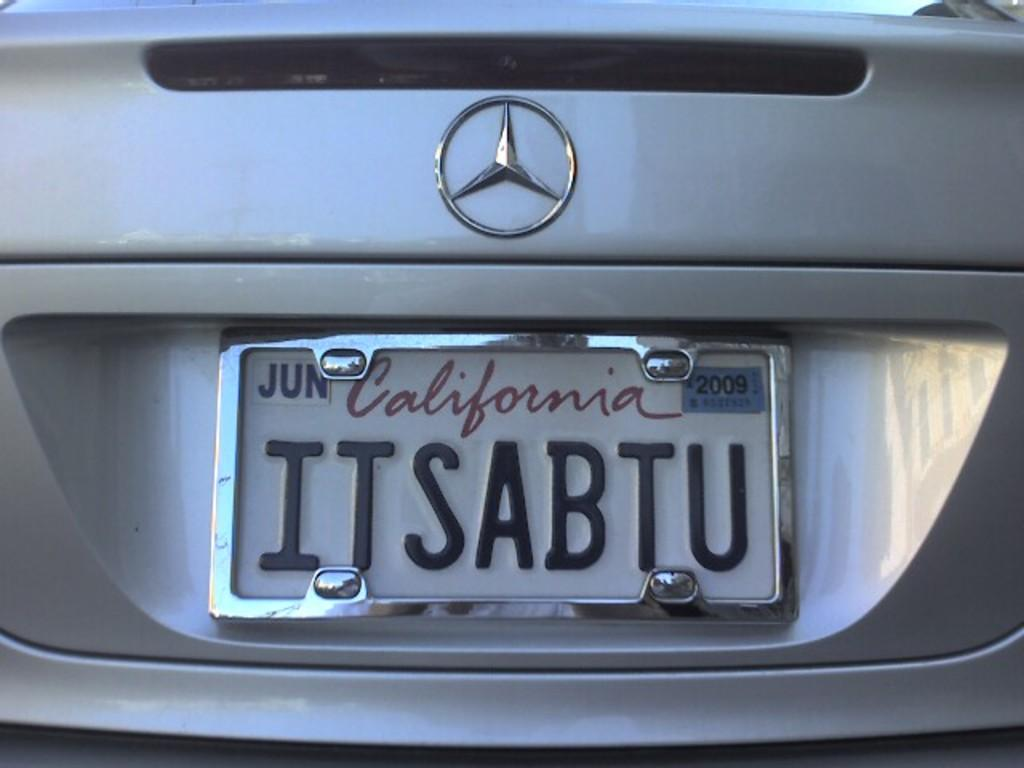<image>
Share a concise interpretation of the image provided. A silver Mercedes with a California tag reading ITSABTU. 